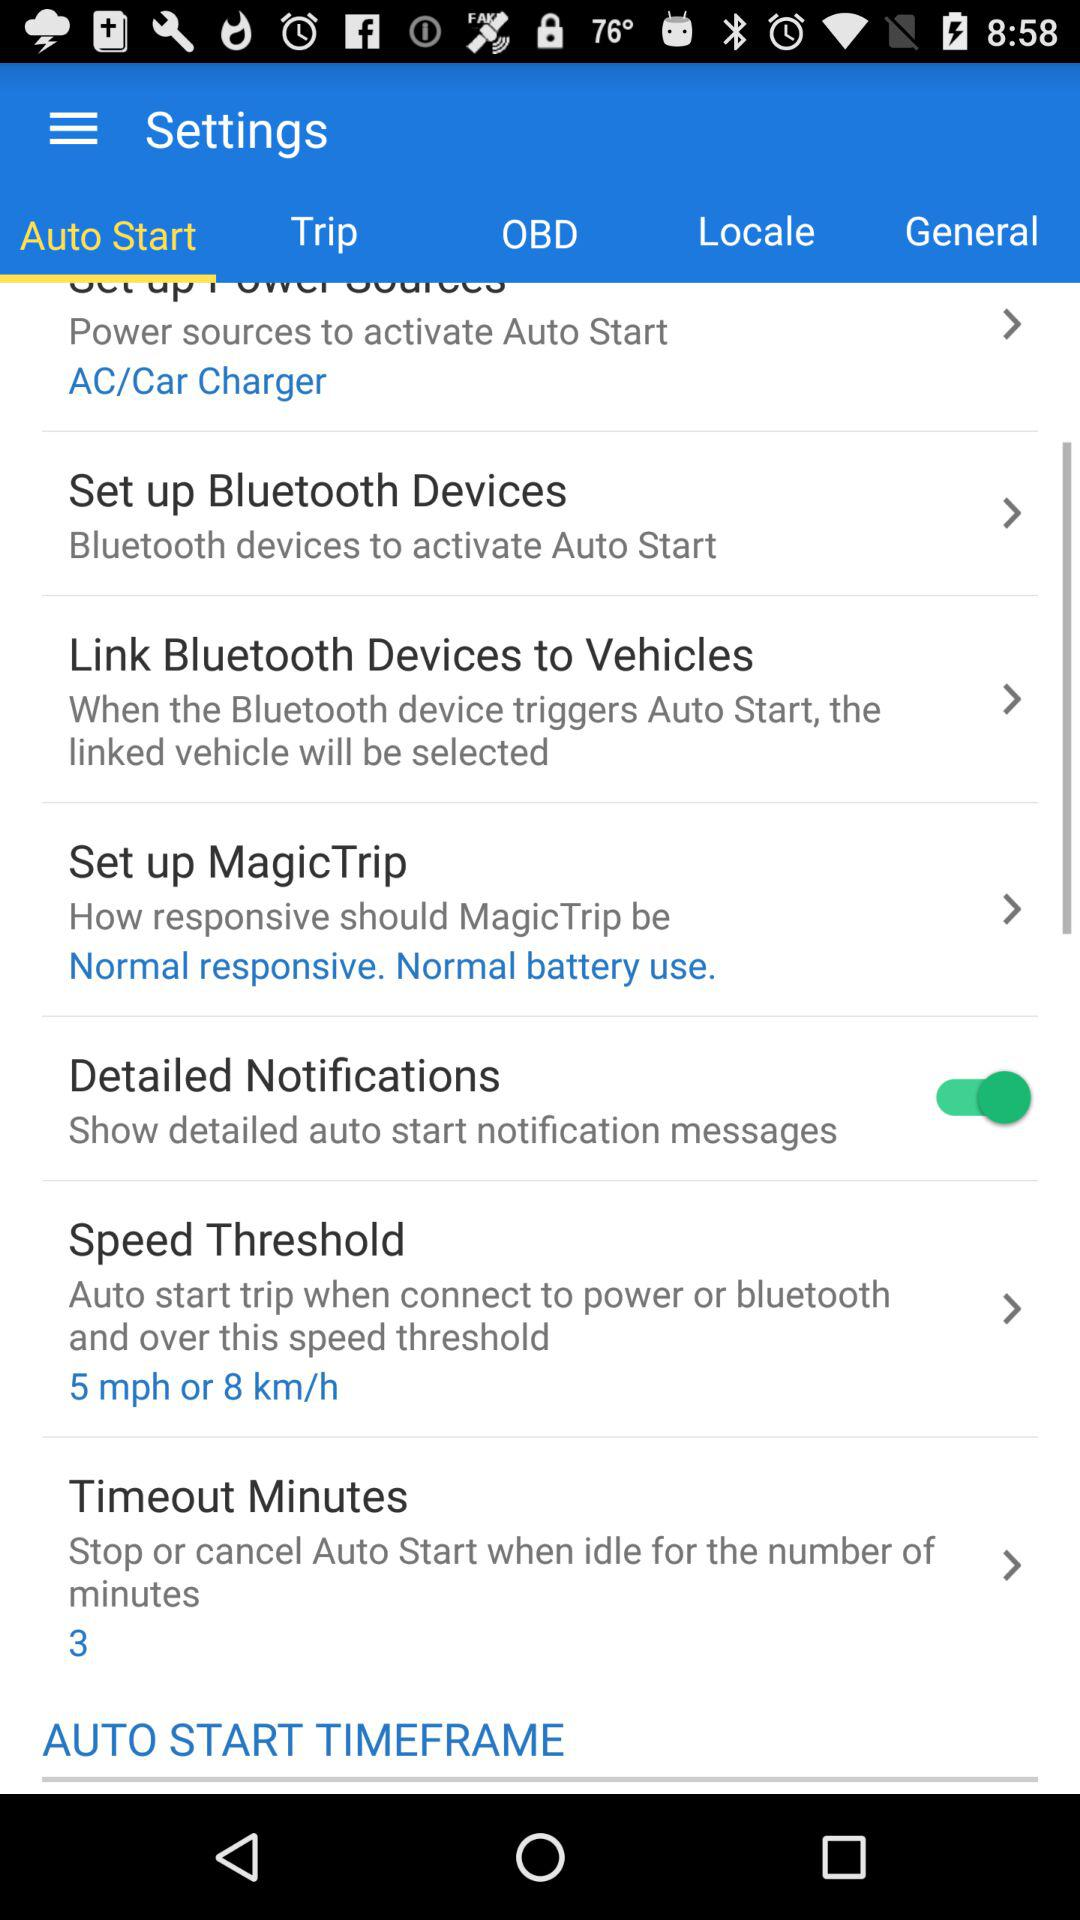Which tab is selected? The selected tab is "Auto Start". 